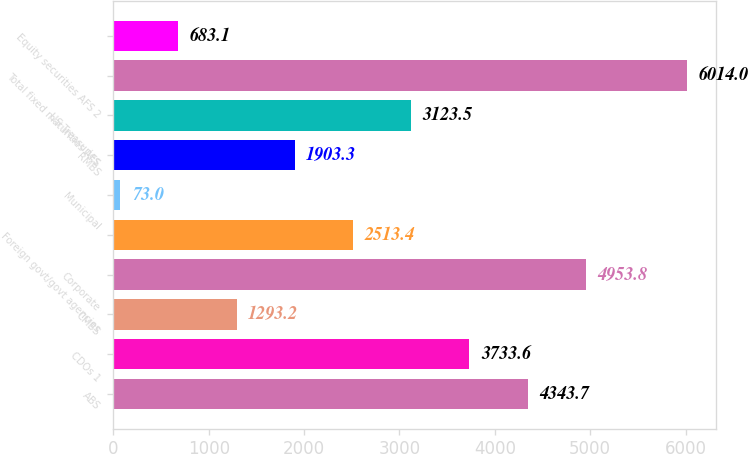Convert chart to OTSL. <chart><loc_0><loc_0><loc_500><loc_500><bar_chart><fcel>ABS<fcel>CDOs 1<fcel>CMBS<fcel>Corporate<fcel>Foreign govt/govt agencies<fcel>Municipal<fcel>RMBS<fcel>US Treasuries<fcel>Total fixed maturities AFS<fcel>Equity securities AFS 2<nl><fcel>4343.7<fcel>3733.6<fcel>1293.2<fcel>4953.8<fcel>2513.4<fcel>73<fcel>1903.3<fcel>3123.5<fcel>6014<fcel>683.1<nl></chart> 